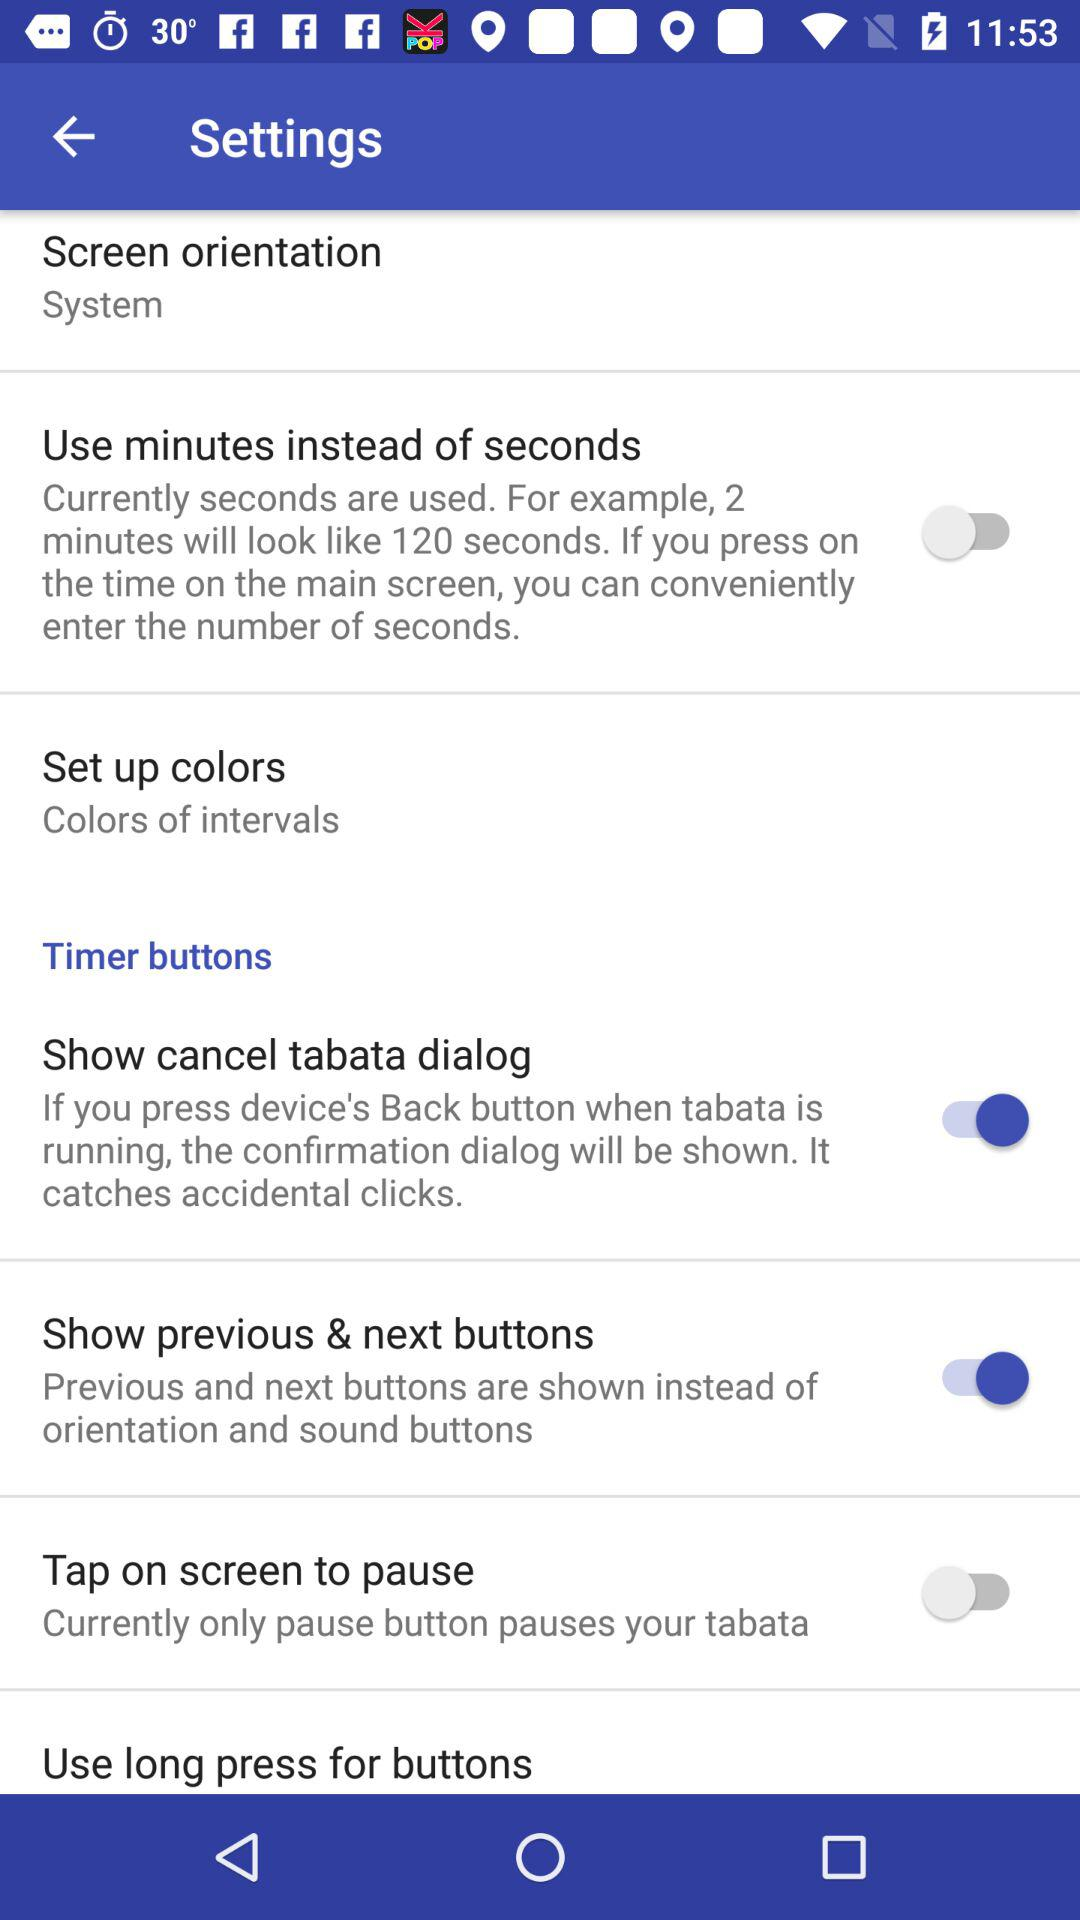What is the status of "Show cancel tabata dialog" setting? The status is "on". 